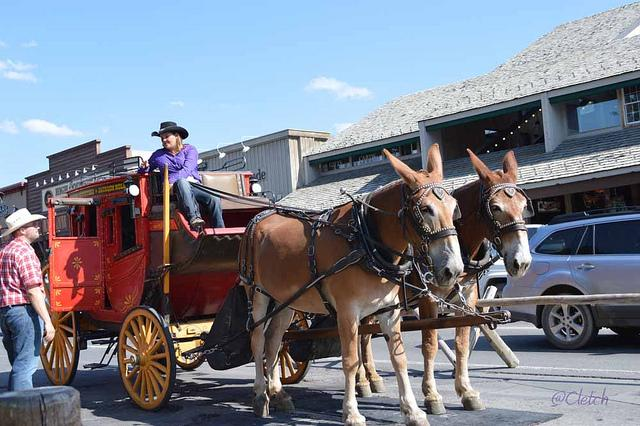What do both of the people have on their heads? cowboy hats 